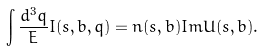Convert formula to latex. <formula><loc_0><loc_0><loc_500><loc_500>\int \frac { d ^ { 3 } q } { E } I ( s , b , q ) = \bar { n } ( s , b ) I m U ( s , b ) .</formula> 